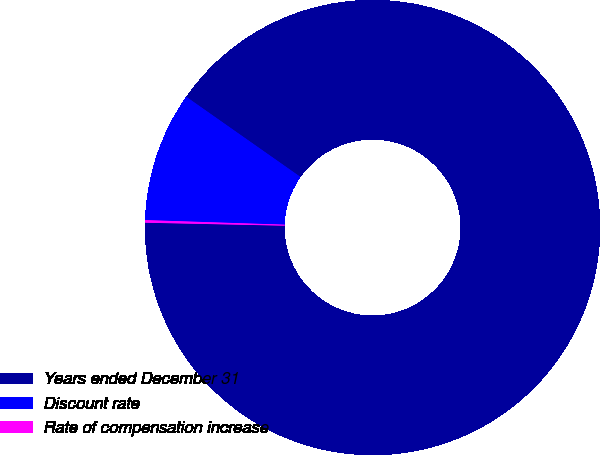Convert chart to OTSL. <chart><loc_0><loc_0><loc_500><loc_500><pie_chart><fcel>Years ended December 31<fcel>Discount rate<fcel>Rate of compensation increase<nl><fcel>90.6%<fcel>9.22%<fcel>0.18%<nl></chart> 